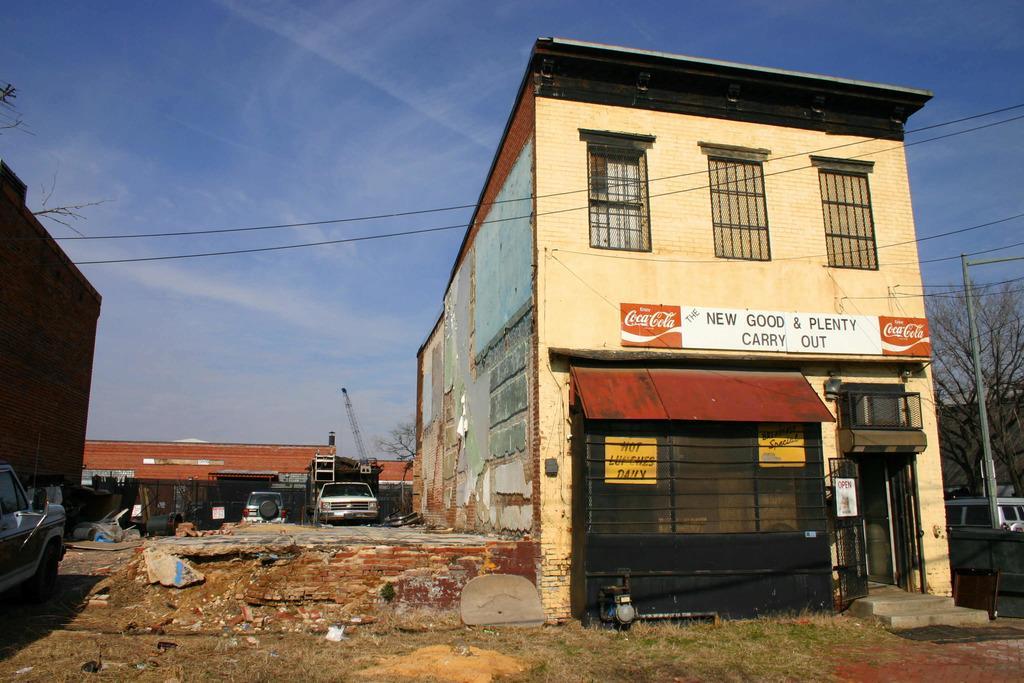Describe this image in one or two sentences. In this picture we can see buildings and vehicles. On the right side of the building there are trees and a pole with cables. Behind the buildings there is the sky. On the building there are boards. 